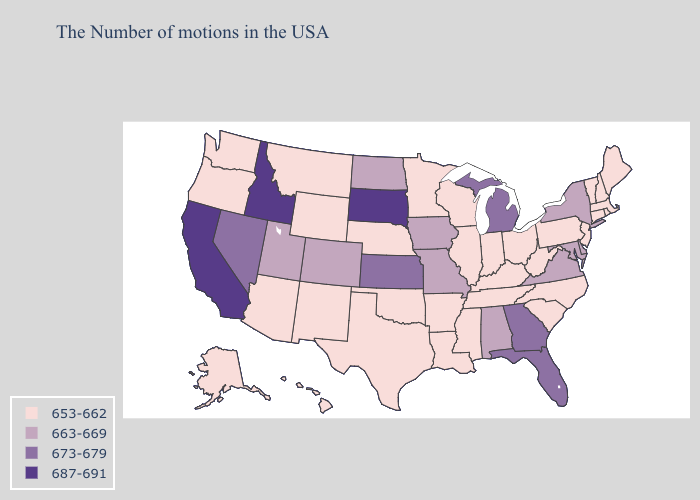Does California have the highest value in the USA?
Concise answer only. Yes. What is the lowest value in states that border Georgia?
Concise answer only. 653-662. Name the states that have a value in the range 687-691?
Write a very short answer. South Dakota, Idaho, California. Which states have the lowest value in the USA?
Short answer required. Maine, Massachusetts, Rhode Island, New Hampshire, Vermont, Connecticut, New Jersey, Pennsylvania, North Carolina, South Carolina, West Virginia, Ohio, Kentucky, Indiana, Tennessee, Wisconsin, Illinois, Mississippi, Louisiana, Arkansas, Minnesota, Nebraska, Oklahoma, Texas, Wyoming, New Mexico, Montana, Arizona, Washington, Oregon, Alaska, Hawaii. What is the highest value in the USA?
Write a very short answer. 687-691. Among the states that border Kansas , which have the lowest value?
Keep it brief. Nebraska, Oklahoma. Name the states that have a value in the range 673-679?
Concise answer only. Florida, Georgia, Michigan, Kansas, Nevada. What is the highest value in states that border Wisconsin?
Be succinct. 673-679. Name the states that have a value in the range 687-691?
Answer briefly. South Dakota, Idaho, California. What is the highest value in the USA?
Answer briefly. 687-691. Among the states that border Mississippi , does Tennessee have the lowest value?
Be succinct. Yes. What is the value of Wyoming?
Be succinct. 653-662. What is the value of Wyoming?
Concise answer only. 653-662. Does New Mexico have a lower value than Alaska?
Write a very short answer. No. Which states have the highest value in the USA?
Quick response, please. South Dakota, Idaho, California. 